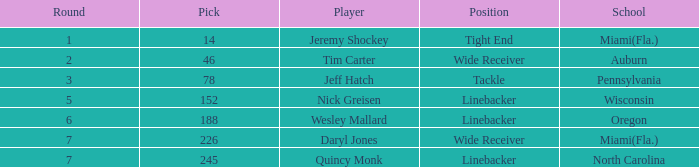From which institution was the athlete selected in the third round? Pennsylvania. 